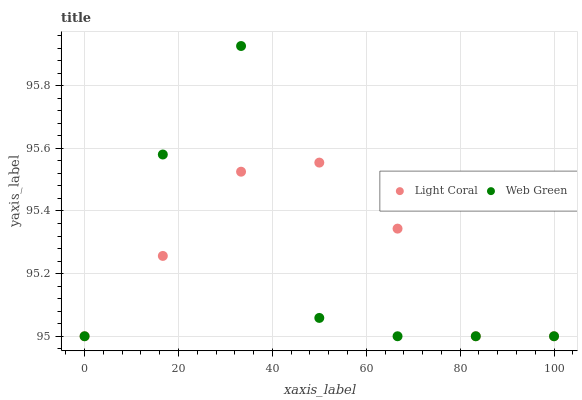Does Web Green have the minimum area under the curve?
Answer yes or no. Yes. Does Light Coral have the maximum area under the curve?
Answer yes or no. Yes. Does Web Green have the maximum area under the curve?
Answer yes or no. No. Is Light Coral the smoothest?
Answer yes or no. Yes. Is Web Green the roughest?
Answer yes or no. Yes. Is Web Green the smoothest?
Answer yes or no. No. Does Light Coral have the lowest value?
Answer yes or no. Yes. Does Web Green have the highest value?
Answer yes or no. Yes. Does Light Coral intersect Web Green?
Answer yes or no. Yes. Is Light Coral less than Web Green?
Answer yes or no. No. Is Light Coral greater than Web Green?
Answer yes or no. No. 